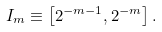<formula> <loc_0><loc_0><loc_500><loc_500>I _ { m } \equiv \left [ 2 ^ { - m - 1 } , 2 ^ { - m } \right ] .</formula> 